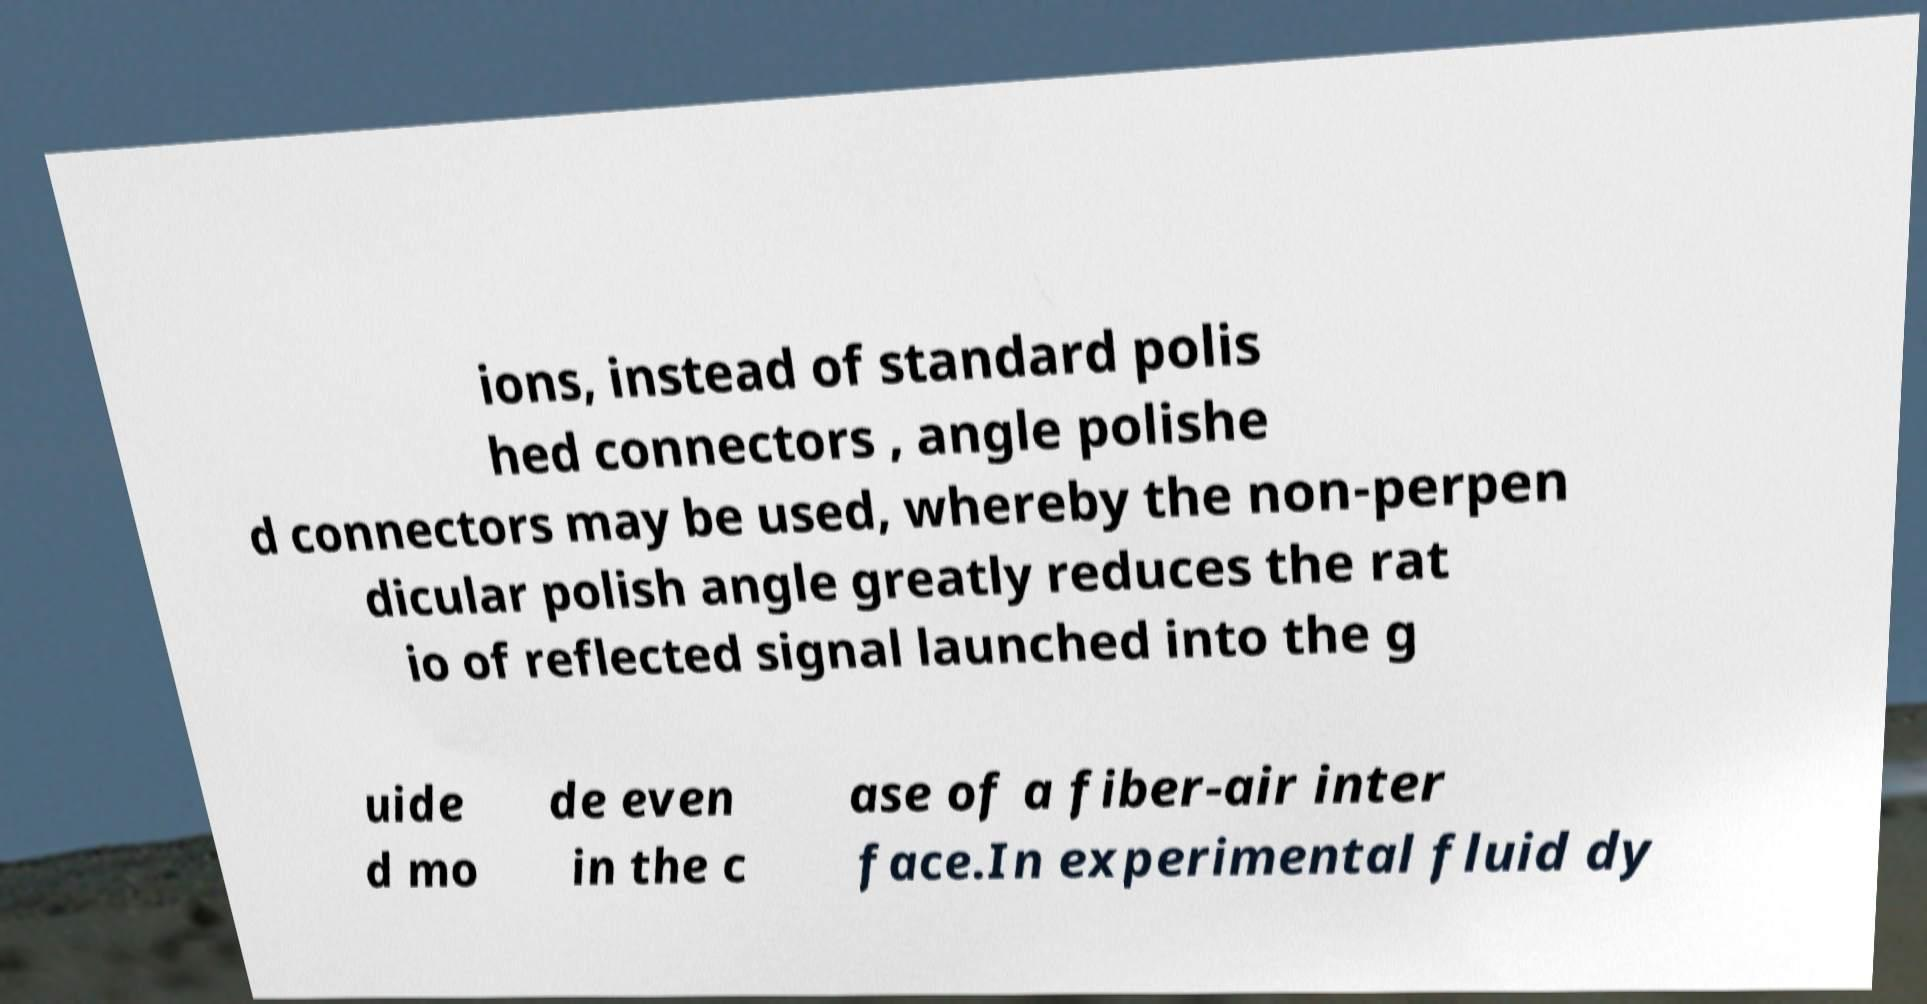Please identify and transcribe the text found in this image. ions, instead of standard polis hed connectors , angle polishe d connectors may be used, whereby the non-perpen dicular polish angle greatly reduces the rat io of reflected signal launched into the g uide d mo de even in the c ase of a fiber-air inter face.In experimental fluid dy 